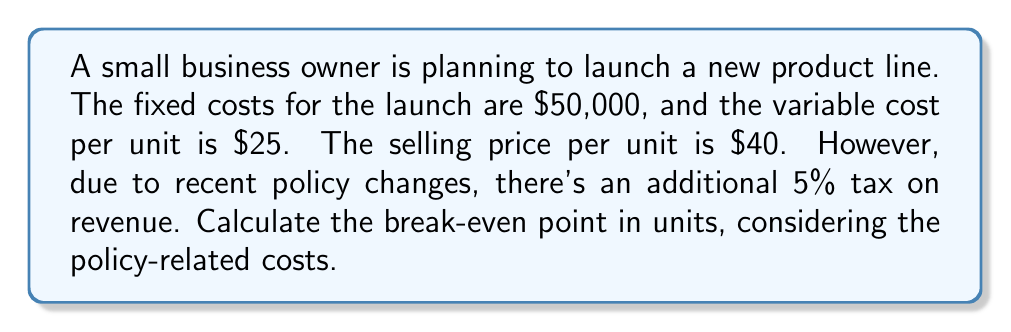Can you answer this question? Let's approach this step-by-step:

1) First, let's define our variables:
   $x$ = number of units sold
   $FC$ = Fixed Costs = $50,000
   $VC$ = Variable Cost per unit = $25
   $SP$ = Selling Price per unit = $40
   $T$ = Tax rate = 5% = 0.05

2) The break-even point is where Total Revenue (TR) equals Total Costs (TC):
   $TR = TC$

3) Let's express TR and TC in terms of $x$:
   $TC = FC + (VC \times x) = 50,000 + 25x$
   $TR = (SP \times x) - (T \times SP \times x) = 40x - 0.05(40x) = 38x$

4) Now, let's set up our break-even equation:
   $38x = 50,000 + 25x$

5) Solve for $x$:
   $38x - 25x = 50,000$
   $13x = 50,000$
   $x = \frac{50,000}{13} \approx 3,846.15$

6) Since we can't sell fractional units, we round up to the nearest whole number:
   $x = 3,847$ units

Therefore, the business needs to sell 3,847 units to break even.
Answer: 3,847 units 